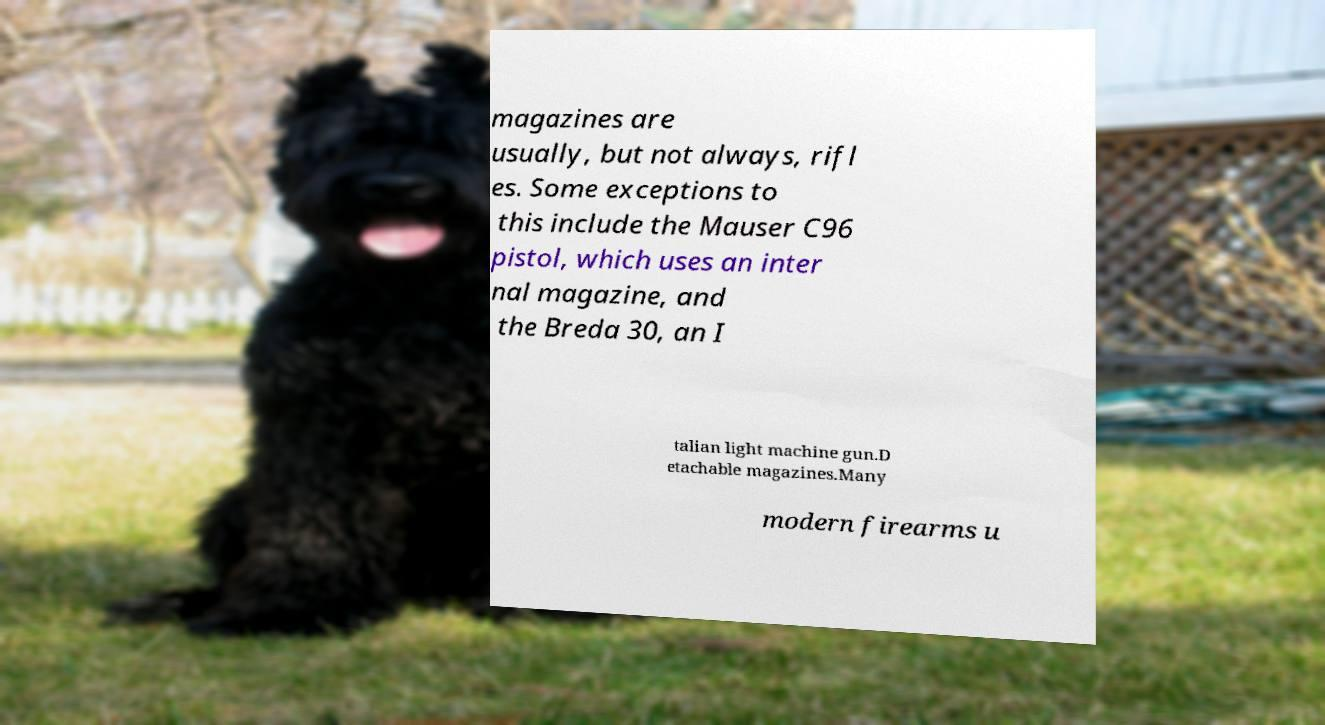I need the written content from this picture converted into text. Can you do that? magazines are usually, but not always, rifl es. Some exceptions to this include the Mauser C96 pistol, which uses an inter nal magazine, and the Breda 30, an I talian light machine gun.D etachable magazines.Many modern firearms u 